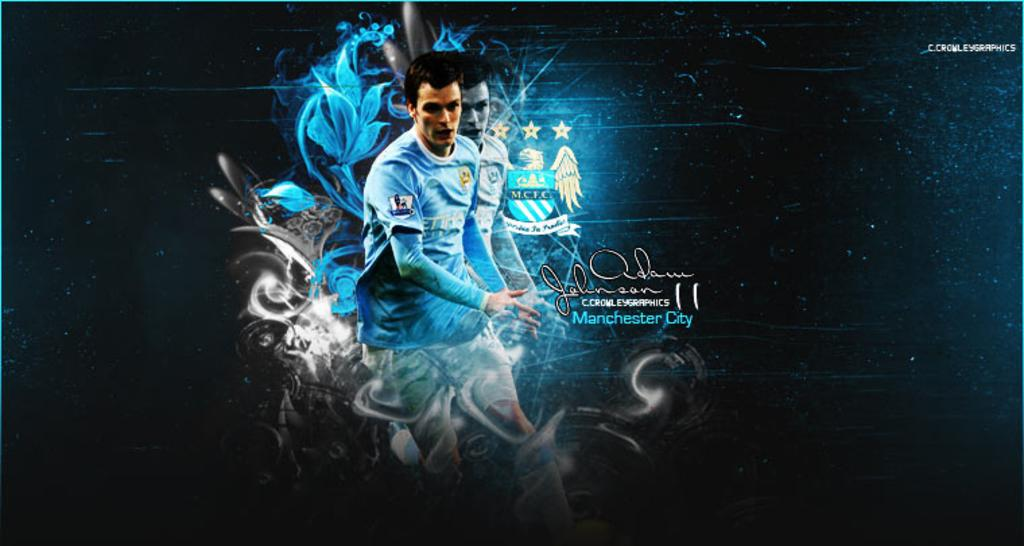<image>
Relay a brief, clear account of the picture shown. A signed print of Adam Johnson from C Crowley Graphics in Manchester City. 